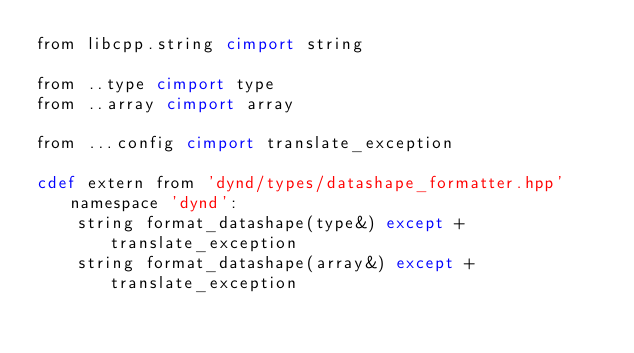Convert code to text. <code><loc_0><loc_0><loc_500><loc_500><_Cython_>from libcpp.string cimport string

from ..type cimport type
from ..array cimport array

from ...config cimport translate_exception

cdef extern from 'dynd/types/datashape_formatter.hpp' namespace 'dynd':
    string format_datashape(type&) except +translate_exception
    string format_datashape(array&) except +translate_exception
</code> 